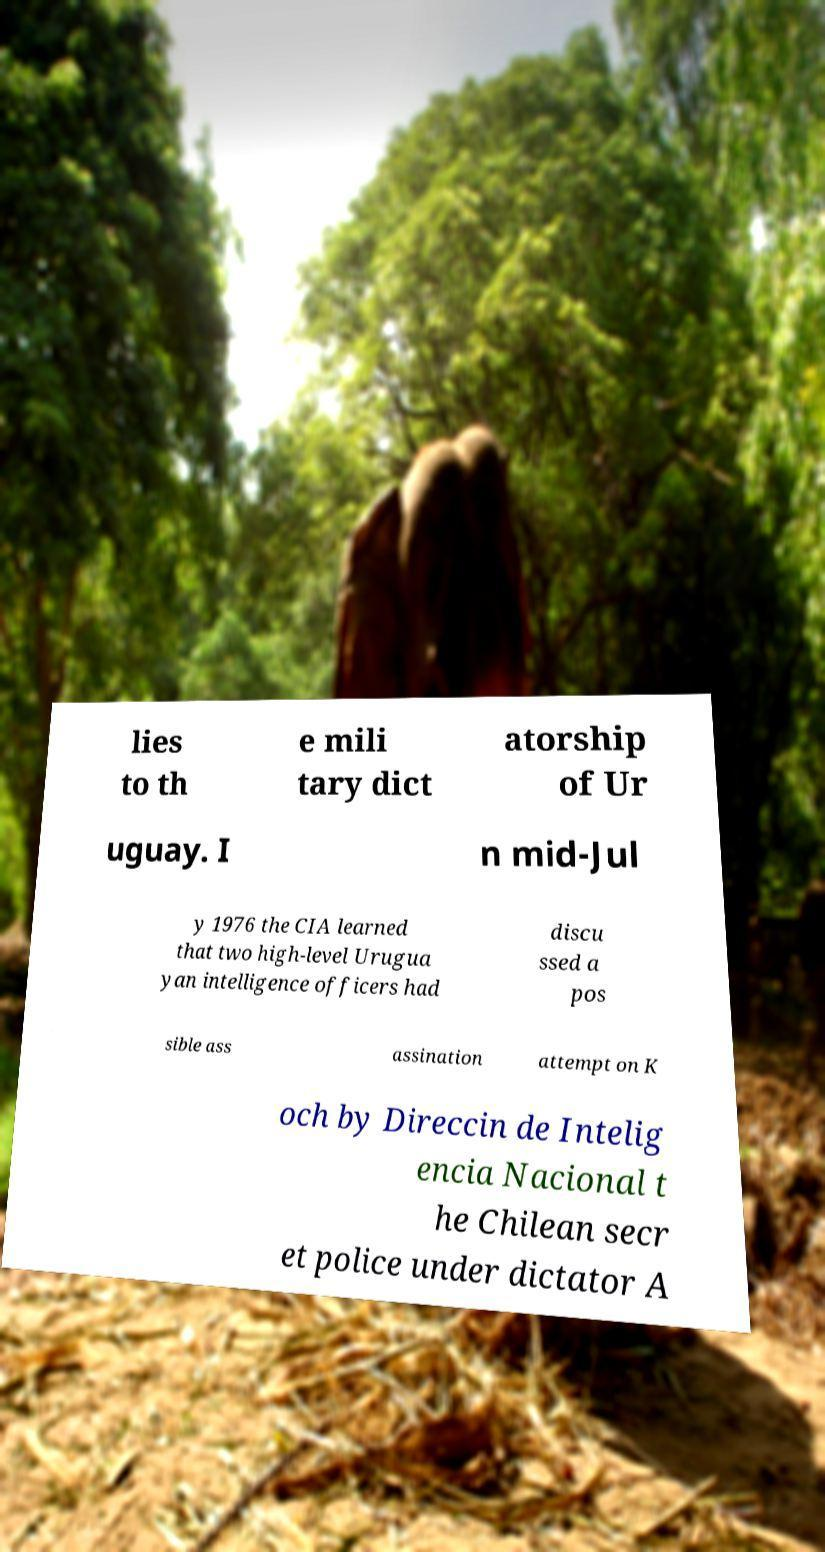What messages or text are displayed in this image? I need them in a readable, typed format. lies to th e mili tary dict atorship of Ur uguay. I n mid-Jul y 1976 the CIA learned that two high-level Urugua yan intelligence officers had discu ssed a pos sible ass assination attempt on K och by Direccin de Intelig encia Nacional t he Chilean secr et police under dictator A 